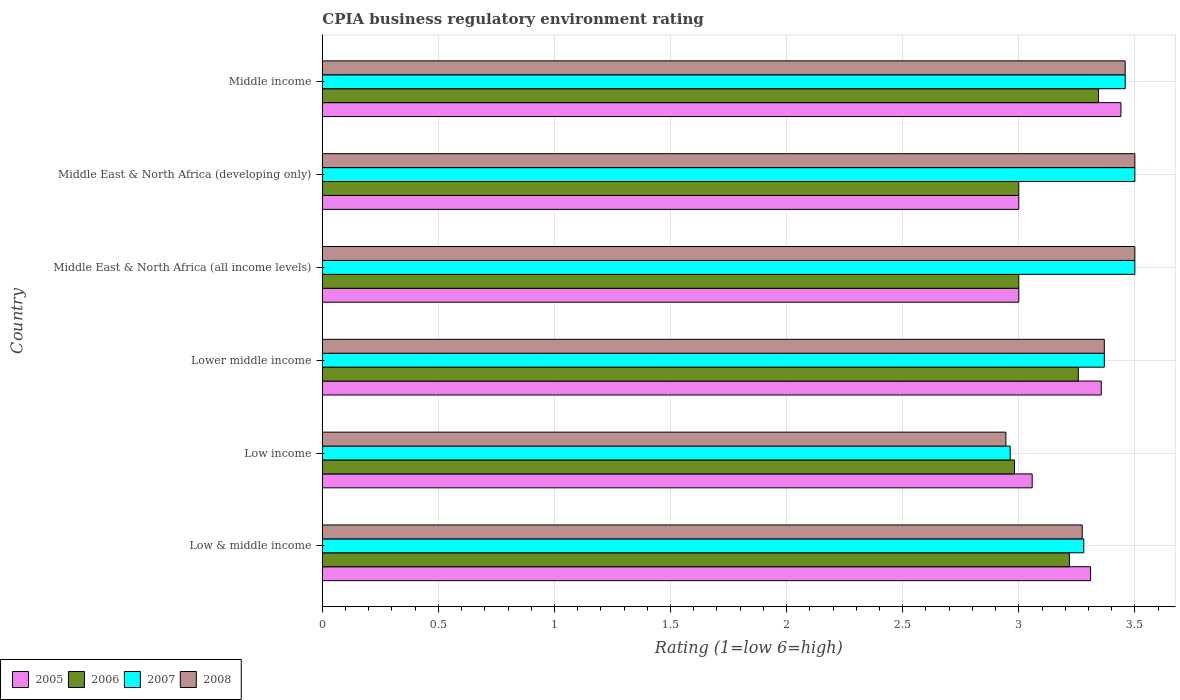How many bars are there on the 3rd tick from the top?
Keep it short and to the point. 4. In how many cases, is the number of bars for a given country not equal to the number of legend labels?
Your answer should be compact. 0. What is the CPIA rating in 2005 in Middle income?
Ensure brevity in your answer.  3.44. Across all countries, what is the maximum CPIA rating in 2006?
Ensure brevity in your answer.  3.34. Across all countries, what is the minimum CPIA rating in 2007?
Offer a terse response. 2.96. In which country was the CPIA rating in 2005 minimum?
Offer a terse response. Middle East & North Africa (all income levels). What is the total CPIA rating in 2005 in the graph?
Your answer should be very brief. 19.16. What is the difference between the CPIA rating in 2006 in Middle East & North Africa (all income levels) and that in Middle East & North Africa (developing only)?
Offer a terse response. 0. What is the difference between the CPIA rating in 2007 in Lower middle income and the CPIA rating in 2005 in Low income?
Offer a terse response. 0.31. What is the average CPIA rating in 2005 per country?
Make the answer very short. 3.19. In how many countries, is the CPIA rating in 2005 greater than 1 ?
Give a very brief answer. 6. What is the ratio of the CPIA rating in 2008 in Lower middle income to that in Middle East & North Africa (developing only)?
Keep it short and to the point. 0.96. What is the difference between the highest and the second highest CPIA rating in 2006?
Your response must be concise. 0.09. What is the difference between the highest and the lowest CPIA rating in 2006?
Provide a succinct answer. 0.36. Is the sum of the CPIA rating in 2005 in Lower middle income and Middle East & North Africa (all income levels) greater than the maximum CPIA rating in 2008 across all countries?
Offer a terse response. Yes. What does the 3rd bar from the bottom in Low & middle income represents?
Ensure brevity in your answer.  2007. How many bars are there?
Offer a terse response. 24. How many countries are there in the graph?
Your answer should be compact. 6. What is the difference between two consecutive major ticks on the X-axis?
Offer a terse response. 0.5. Does the graph contain any zero values?
Your response must be concise. No. Does the graph contain grids?
Your answer should be compact. Yes. Where does the legend appear in the graph?
Your answer should be compact. Bottom left. How are the legend labels stacked?
Your answer should be very brief. Horizontal. What is the title of the graph?
Keep it short and to the point. CPIA business regulatory environment rating. What is the label or title of the Y-axis?
Your answer should be compact. Country. What is the Rating (1=low 6=high) of 2005 in Low & middle income?
Keep it short and to the point. 3.31. What is the Rating (1=low 6=high) in 2006 in Low & middle income?
Your answer should be very brief. 3.22. What is the Rating (1=low 6=high) of 2007 in Low & middle income?
Your response must be concise. 3.28. What is the Rating (1=low 6=high) of 2008 in Low & middle income?
Give a very brief answer. 3.27. What is the Rating (1=low 6=high) in 2005 in Low income?
Provide a short and direct response. 3.06. What is the Rating (1=low 6=high) in 2006 in Low income?
Keep it short and to the point. 2.98. What is the Rating (1=low 6=high) in 2007 in Low income?
Offer a terse response. 2.96. What is the Rating (1=low 6=high) in 2008 in Low income?
Your response must be concise. 2.94. What is the Rating (1=low 6=high) of 2005 in Lower middle income?
Your answer should be very brief. 3.36. What is the Rating (1=low 6=high) of 2006 in Lower middle income?
Provide a short and direct response. 3.26. What is the Rating (1=low 6=high) in 2007 in Lower middle income?
Your answer should be compact. 3.37. What is the Rating (1=low 6=high) in 2008 in Lower middle income?
Your response must be concise. 3.37. What is the Rating (1=low 6=high) of 2005 in Middle East & North Africa (all income levels)?
Provide a succinct answer. 3. What is the Rating (1=low 6=high) in 2007 in Middle East & North Africa (all income levels)?
Provide a succinct answer. 3.5. What is the Rating (1=low 6=high) of 2005 in Middle East & North Africa (developing only)?
Your response must be concise. 3. What is the Rating (1=low 6=high) in 2007 in Middle East & North Africa (developing only)?
Offer a very short reply. 3.5. What is the Rating (1=low 6=high) of 2008 in Middle East & North Africa (developing only)?
Provide a short and direct response. 3.5. What is the Rating (1=low 6=high) in 2005 in Middle income?
Provide a short and direct response. 3.44. What is the Rating (1=low 6=high) in 2006 in Middle income?
Keep it short and to the point. 3.34. What is the Rating (1=low 6=high) of 2007 in Middle income?
Provide a succinct answer. 3.46. What is the Rating (1=low 6=high) in 2008 in Middle income?
Keep it short and to the point. 3.46. Across all countries, what is the maximum Rating (1=low 6=high) of 2005?
Keep it short and to the point. 3.44. Across all countries, what is the maximum Rating (1=low 6=high) in 2006?
Offer a very short reply. 3.34. Across all countries, what is the maximum Rating (1=low 6=high) in 2007?
Provide a short and direct response. 3.5. Across all countries, what is the minimum Rating (1=low 6=high) in 2006?
Your answer should be compact. 2.98. Across all countries, what is the minimum Rating (1=low 6=high) in 2007?
Offer a terse response. 2.96. Across all countries, what is the minimum Rating (1=low 6=high) of 2008?
Offer a terse response. 2.94. What is the total Rating (1=low 6=high) in 2005 in the graph?
Keep it short and to the point. 19.16. What is the total Rating (1=low 6=high) in 2006 in the graph?
Ensure brevity in your answer.  18.8. What is the total Rating (1=low 6=high) of 2007 in the graph?
Offer a very short reply. 20.07. What is the total Rating (1=low 6=high) of 2008 in the graph?
Your answer should be compact. 20.04. What is the difference between the Rating (1=low 6=high) of 2005 in Low & middle income and that in Low income?
Your answer should be very brief. 0.25. What is the difference between the Rating (1=low 6=high) in 2006 in Low & middle income and that in Low income?
Give a very brief answer. 0.24. What is the difference between the Rating (1=low 6=high) of 2007 in Low & middle income and that in Low income?
Give a very brief answer. 0.32. What is the difference between the Rating (1=low 6=high) in 2008 in Low & middle income and that in Low income?
Provide a short and direct response. 0.33. What is the difference between the Rating (1=low 6=high) in 2005 in Low & middle income and that in Lower middle income?
Your answer should be very brief. -0.05. What is the difference between the Rating (1=low 6=high) of 2006 in Low & middle income and that in Lower middle income?
Offer a very short reply. -0.04. What is the difference between the Rating (1=low 6=high) of 2007 in Low & middle income and that in Lower middle income?
Provide a succinct answer. -0.09. What is the difference between the Rating (1=low 6=high) in 2008 in Low & middle income and that in Lower middle income?
Give a very brief answer. -0.1. What is the difference between the Rating (1=low 6=high) of 2005 in Low & middle income and that in Middle East & North Africa (all income levels)?
Provide a succinct answer. 0.31. What is the difference between the Rating (1=low 6=high) of 2006 in Low & middle income and that in Middle East & North Africa (all income levels)?
Offer a very short reply. 0.22. What is the difference between the Rating (1=low 6=high) of 2007 in Low & middle income and that in Middle East & North Africa (all income levels)?
Your answer should be compact. -0.22. What is the difference between the Rating (1=low 6=high) of 2008 in Low & middle income and that in Middle East & North Africa (all income levels)?
Keep it short and to the point. -0.23. What is the difference between the Rating (1=low 6=high) of 2005 in Low & middle income and that in Middle East & North Africa (developing only)?
Give a very brief answer. 0.31. What is the difference between the Rating (1=low 6=high) in 2006 in Low & middle income and that in Middle East & North Africa (developing only)?
Provide a succinct answer. 0.22. What is the difference between the Rating (1=low 6=high) in 2007 in Low & middle income and that in Middle East & North Africa (developing only)?
Keep it short and to the point. -0.22. What is the difference between the Rating (1=low 6=high) in 2008 in Low & middle income and that in Middle East & North Africa (developing only)?
Offer a terse response. -0.23. What is the difference between the Rating (1=low 6=high) of 2005 in Low & middle income and that in Middle income?
Provide a succinct answer. -0.13. What is the difference between the Rating (1=low 6=high) of 2006 in Low & middle income and that in Middle income?
Provide a succinct answer. -0.13. What is the difference between the Rating (1=low 6=high) in 2007 in Low & middle income and that in Middle income?
Offer a terse response. -0.18. What is the difference between the Rating (1=low 6=high) in 2008 in Low & middle income and that in Middle income?
Your response must be concise. -0.18. What is the difference between the Rating (1=low 6=high) in 2005 in Low income and that in Lower middle income?
Provide a succinct answer. -0.3. What is the difference between the Rating (1=low 6=high) of 2006 in Low income and that in Lower middle income?
Your response must be concise. -0.27. What is the difference between the Rating (1=low 6=high) of 2007 in Low income and that in Lower middle income?
Provide a short and direct response. -0.41. What is the difference between the Rating (1=low 6=high) of 2008 in Low income and that in Lower middle income?
Your answer should be compact. -0.42. What is the difference between the Rating (1=low 6=high) in 2005 in Low income and that in Middle East & North Africa (all income levels)?
Your response must be concise. 0.06. What is the difference between the Rating (1=low 6=high) of 2006 in Low income and that in Middle East & North Africa (all income levels)?
Your answer should be very brief. -0.02. What is the difference between the Rating (1=low 6=high) of 2007 in Low income and that in Middle East & North Africa (all income levels)?
Give a very brief answer. -0.54. What is the difference between the Rating (1=low 6=high) in 2008 in Low income and that in Middle East & North Africa (all income levels)?
Keep it short and to the point. -0.56. What is the difference between the Rating (1=low 6=high) of 2005 in Low income and that in Middle East & North Africa (developing only)?
Your answer should be very brief. 0.06. What is the difference between the Rating (1=low 6=high) of 2006 in Low income and that in Middle East & North Africa (developing only)?
Your response must be concise. -0.02. What is the difference between the Rating (1=low 6=high) in 2007 in Low income and that in Middle East & North Africa (developing only)?
Keep it short and to the point. -0.54. What is the difference between the Rating (1=low 6=high) of 2008 in Low income and that in Middle East & North Africa (developing only)?
Provide a short and direct response. -0.56. What is the difference between the Rating (1=low 6=high) in 2005 in Low income and that in Middle income?
Give a very brief answer. -0.38. What is the difference between the Rating (1=low 6=high) of 2006 in Low income and that in Middle income?
Ensure brevity in your answer.  -0.36. What is the difference between the Rating (1=low 6=high) in 2007 in Low income and that in Middle income?
Offer a terse response. -0.5. What is the difference between the Rating (1=low 6=high) in 2008 in Low income and that in Middle income?
Offer a terse response. -0.51. What is the difference between the Rating (1=low 6=high) of 2005 in Lower middle income and that in Middle East & North Africa (all income levels)?
Ensure brevity in your answer.  0.36. What is the difference between the Rating (1=low 6=high) of 2006 in Lower middle income and that in Middle East & North Africa (all income levels)?
Offer a terse response. 0.26. What is the difference between the Rating (1=low 6=high) of 2007 in Lower middle income and that in Middle East & North Africa (all income levels)?
Provide a short and direct response. -0.13. What is the difference between the Rating (1=low 6=high) of 2008 in Lower middle income and that in Middle East & North Africa (all income levels)?
Your response must be concise. -0.13. What is the difference between the Rating (1=low 6=high) of 2005 in Lower middle income and that in Middle East & North Africa (developing only)?
Offer a very short reply. 0.36. What is the difference between the Rating (1=low 6=high) of 2006 in Lower middle income and that in Middle East & North Africa (developing only)?
Give a very brief answer. 0.26. What is the difference between the Rating (1=low 6=high) in 2007 in Lower middle income and that in Middle East & North Africa (developing only)?
Give a very brief answer. -0.13. What is the difference between the Rating (1=low 6=high) of 2008 in Lower middle income and that in Middle East & North Africa (developing only)?
Your response must be concise. -0.13. What is the difference between the Rating (1=low 6=high) of 2005 in Lower middle income and that in Middle income?
Your answer should be very brief. -0.08. What is the difference between the Rating (1=low 6=high) of 2006 in Lower middle income and that in Middle income?
Offer a very short reply. -0.09. What is the difference between the Rating (1=low 6=high) of 2007 in Lower middle income and that in Middle income?
Your answer should be very brief. -0.09. What is the difference between the Rating (1=low 6=high) in 2008 in Lower middle income and that in Middle income?
Provide a short and direct response. -0.09. What is the difference between the Rating (1=low 6=high) of 2005 in Middle East & North Africa (all income levels) and that in Middle income?
Your answer should be compact. -0.44. What is the difference between the Rating (1=low 6=high) in 2006 in Middle East & North Africa (all income levels) and that in Middle income?
Ensure brevity in your answer.  -0.34. What is the difference between the Rating (1=low 6=high) in 2007 in Middle East & North Africa (all income levels) and that in Middle income?
Offer a terse response. 0.04. What is the difference between the Rating (1=low 6=high) of 2008 in Middle East & North Africa (all income levels) and that in Middle income?
Offer a very short reply. 0.04. What is the difference between the Rating (1=low 6=high) of 2005 in Middle East & North Africa (developing only) and that in Middle income?
Give a very brief answer. -0.44. What is the difference between the Rating (1=low 6=high) of 2006 in Middle East & North Africa (developing only) and that in Middle income?
Your answer should be very brief. -0.34. What is the difference between the Rating (1=low 6=high) of 2007 in Middle East & North Africa (developing only) and that in Middle income?
Offer a very short reply. 0.04. What is the difference between the Rating (1=low 6=high) of 2008 in Middle East & North Africa (developing only) and that in Middle income?
Your answer should be compact. 0.04. What is the difference between the Rating (1=low 6=high) in 2005 in Low & middle income and the Rating (1=low 6=high) in 2006 in Low income?
Keep it short and to the point. 0.33. What is the difference between the Rating (1=low 6=high) in 2005 in Low & middle income and the Rating (1=low 6=high) in 2007 in Low income?
Provide a short and direct response. 0.35. What is the difference between the Rating (1=low 6=high) in 2005 in Low & middle income and the Rating (1=low 6=high) in 2008 in Low income?
Offer a terse response. 0.36. What is the difference between the Rating (1=low 6=high) in 2006 in Low & middle income and the Rating (1=low 6=high) in 2007 in Low income?
Your response must be concise. 0.26. What is the difference between the Rating (1=low 6=high) in 2006 in Low & middle income and the Rating (1=low 6=high) in 2008 in Low income?
Keep it short and to the point. 0.27. What is the difference between the Rating (1=low 6=high) of 2007 in Low & middle income and the Rating (1=low 6=high) of 2008 in Low income?
Your answer should be compact. 0.34. What is the difference between the Rating (1=low 6=high) in 2005 in Low & middle income and the Rating (1=low 6=high) in 2006 in Lower middle income?
Offer a very short reply. 0.05. What is the difference between the Rating (1=low 6=high) in 2005 in Low & middle income and the Rating (1=low 6=high) in 2007 in Lower middle income?
Your answer should be compact. -0.06. What is the difference between the Rating (1=low 6=high) of 2005 in Low & middle income and the Rating (1=low 6=high) of 2008 in Lower middle income?
Offer a terse response. -0.06. What is the difference between the Rating (1=low 6=high) of 2006 in Low & middle income and the Rating (1=low 6=high) of 2007 in Lower middle income?
Make the answer very short. -0.15. What is the difference between the Rating (1=low 6=high) of 2006 in Low & middle income and the Rating (1=low 6=high) of 2008 in Lower middle income?
Provide a short and direct response. -0.15. What is the difference between the Rating (1=low 6=high) of 2007 in Low & middle income and the Rating (1=low 6=high) of 2008 in Lower middle income?
Make the answer very short. -0.09. What is the difference between the Rating (1=low 6=high) of 2005 in Low & middle income and the Rating (1=low 6=high) of 2006 in Middle East & North Africa (all income levels)?
Your response must be concise. 0.31. What is the difference between the Rating (1=low 6=high) of 2005 in Low & middle income and the Rating (1=low 6=high) of 2007 in Middle East & North Africa (all income levels)?
Offer a terse response. -0.19. What is the difference between the Rating (1=low 6=high) in 2005 in Low & middle income and the Rating (1=low 6=high) in 2008 in Middle East & North Africa (all income levels)?
Offer a terse response. -0.19. What is the difference between the Rating (1=low 6=high) of 2006 in Low & middle income and the Rating (1=low 6=high) of 2007 in Middle East & North Africa (all income levels)?
Keep it short and to the point. -0.28. What is the difference between the Rating (1=low 6=high) of 2006 in Low & middle income and the Rating (1=low 6=high) of 2008 in Middle East & North Africa (all income levels)?
Your answer should be very brief. -0.28. What is the difference between the Rating (1=low 6=high) in 2007 in Low & middle income and the Rating (1=low 6=high) in 2008 in Middle East & North Africa (all income levels)?
Give a very brief answer. -0.22. What is the difference between the Rating (1=low 6=high) of 2005 in Low & middle income and the Rating (1=low 6=high) of 2006 in Middle East & North Africa (developing only)?
Ensure brevity in your answer.  0.31. What is the difference between the Rating (1=low 6=high) in 2005 in Low & middle income and the Rating (1=low 6=high) in 2007 in Middle East & North Africa (developing only)?
Keep it short and to the point. -0.19. What is the difference between the Rating (1=low 6=high) in 2005 in Low & middle income and the Rating (1=low 6=high) in 2008 in Middle East & North Africa (developing only)?
Your answer should be very brief. -0.19. What is the difference between the Rating (1=low 6=high) in 2006 in Low & middle income and the Rating (1=low 6=high) in 2007 in Middle East & North Africa (developing only)?
Your answer should be compact. -0.28. What is the difference between the Rating (1=low 6=high) in 2006 in Low & middle income and the Rating (1=low 6=high) in 2008 in Middle East & North Africa (developing only)?
Keep it short and to the point. -0.28. What is the difference between the Rating (1=low 6=high) of 2007 in Low & middle income and the Rating (1=low 6=high) of 2008 in Middle East & North Africa (developing only)?
Give a very brief answer. -0.22. What is the difference between the Rating (1=low 6=high) of 2005 in Low & middle income and the Rating (1=low 6=high) of 2006 in Middle income?
Your answer should be compact. -0.03. What is the difference between the Rating (1=low 6=high) in 2005 in Low & middle income and the Rating (1=low 6=high) in 2007 in Middle income?
Keep it short and to the point. -0.15. What is the difference between the Rating (1=low 6=high) in 2005 in Low & middle income and the Rating (1=low 6=high) in 2008 in Middle income?
Offer a terse response. -0.15. What is the difference between the Rating (1=low 6=high) of 2006 in Low & middle income and the Rating (1=low 6=high) of 2007 in Middle income?
Your answer should be very brief. -0.24. What is the difference between the Rating (1=low 6=high) of 2006 in Low & middle income and the Rating (1=low 6=high) of 2008 in Middle income?
Ensure brevity in your answer.  -0.24. What is the difference between the Rating (1=low 6=high) of 2007 in Low & middle income and the Rating (1=low 6=high) of 2008 in Middle income?
Your answer should be very brief. -0.18. What is the difference between the Rating (1=low 6=high) of 2005 in Low income and the Rating (1=low 6=high) of 2006 in Lower middle income?
Offer a very short reply. -0.2. What is the difference between the Rating (1=low 6=high) in 2005 in Low income and the Rating (1=low 6=high) in 2007 in Lower middle income?
Offer a terse response. -0.31. What is the difference between the Rating (1=low 6=high) of 2005 in Low income and the Rating (1=low 6=high) of 2008 in Lower middle income?
Make the answer very short. -0.31. What is the difference between the Rating (1=low 6=high) of 2006 in Low income and the Rating (1=low 6=high) of 2007 in Lower middle income?
Your response must be concise. -0.39. What is the difference between the Rating (1=low 6=high) in 2006 in Low income and the Rating (1=low 6=high) in 2008 in Lower middle income?
Make the answer very short. -0.39. What is the difference between the Rating (1=low 6=high) of 2007 in Low income and the Rating (1=low 6=high) of 2008 in Lower middle income?
Keep it short and to the point. -0.41. What is the difference between the Rating (1=low 6=high) in 2005 in Low income and the Rating (1=low 6=high) in 2006 in Middle East & North Africa (all income levels)?
Your response must be concise. 0.06. What is the difference between the Rating (1=low 6=high) in 2005 in Low income and the Rating (1=low 6=high) in 2007 in Middle East & North Africa (all income levels)?
Your response must be concise. -0.44. What is the difference between the Rating (1=low 6=high) of 2005 in Low income and the Rating (1=low 6=high) of 2008 in Middle East & North Africa (all income levels)?
Provide a succinct answer. -0.44. What is the difference between the Rating (1=low 6=high) of 2006 in Low income and the Rating (1=low 6=high) of 2007 in Middle East & North Africa (all income levels)?
Make the answer very short. -0.52. What is the difference between the Rating (1=low 6=high) of 2006 in Low income and the Rating (1=low 6=high) of 2008 in Middle East & North Africa (all income levels)?
Keep it short and to the point. -0.52. What is the difference between the Rating (1=low 6=high) of 2007 in Low income and the Rating (1=low 6=high) of 2008 in Middle East & North Africa (all income levels)?
Keep it short and to the point. -0.54. What is the difference between the Rating (1=low 6=high) of 2005 in Low income and the Rating (1=low 6=high) of 2006 in Middle East & North Africa (developing only)?
Provide a short and direct response. 0.06. What is the difference between the Rating (1=low 6=high) in 2005 in Low income and the Rating (1=low 6=high) in 2007 in Middle East & North Africa (developing only)?
Your answer should be very brief. -0.44. What is the difference between the Rating (1=low 6=high) of 2005 in Low income and the Rating (1=low 6=high) of 2008 in Middle East & North Africa (developing only)?
Make the answer very short. -0.44. What is the difference between the Rating (1=low 6=high) in 2006 in Low income and the Rating (1=low 6=high) in 2007 in Middle East & North Africa (developing only)?
Give a very brief answer. -0.52. What is the difference between the Rating (1=low 6=high) of 2006 in Low income and the Rating (1=low 6=high) of 2008 in Middle East & North Africa (developing only)?
Provide a succinct answer. -0.52. What is the difference between the Rating (1=low 6=high) of 2007 in Low income and the Rating (1=low 6=high) of 2008 in Middle East & North Africa (developing only)?
Offer a very short reply. -0.54. What is the difference between the Rating (1=low 6=high) of 2005 in Low income and the Rating (1=low 6=high) of 2006 in Middle income?
Your answer should be compact. -0.29. What is the difference between the Rating (1=low 6=high) of 2005 in Low income and the Rating (1=low 6=high) of 2007 in Middle income?
Your response must be concise. -0.4. What is the difference between the Rating (1=low 6=high) in 2005 in Low income and the Rating (1=low 6=high) in 2008 in Middle income?
Your answer should be compact. -0.4. What is the difference between the Rating (1=low 6=high) of 2006 in Low income and the Rating (1=low 6=high) of 2007 in Middle income?
Provide a succinct answer. -0.48. What is the difference between the Rating (1=low 6=high) in 2006 in Low income and the Rating (1=low 6=high) in 2008 in Middle income?
Your answer should be compact. -0.48. What is the difference between the Rating (1=low 6=high) in 2007 in Low income and the Rating (1=low 6=high) in 2008 in Middle income?
Give a very brief answer. -0.5. What is the difference between the Rating (1=low 6=high) in 2005 in Lower middle income and the Rating (1=low 6=high) in 2006 in Middle East & North Africa (all income levels)?
Keep it short and to the point. 0.36. What is the difference between the Rating (1=low 6=high) of 2005 in Lower middle income and the Rating (1=low 6=high) of 2007 in Middle East & North Africa (all income levels)?
Make the answer very short. -0.14. What is the difference between the Rating (1=low 6=high) of 2005 in Lower middle income and the Rating (1=low 6=high) of 2008 in Middle East & North Africa (all income levels)?
Provide a succinct answer. -0.14. What is the difference between the Rating (1=low 6=high) of 2006 in Lower middle income and the Rating (1=low 6=high) of 2007 in Middle East & North Africa (all income levels)?
Provide a short and direct response. -0.24. What is the difference between the Rating (1=low 6=high) in 2006 in Lower middle income and the Rating (1=low 6=high) in 2008 in Middle East & North Africa (all income levels)?
Provide a short and direct response. -0.24. What is the difference between the Rating (1=low 6=high) in 2007 in Lower middle income and the Rating (1=low 6=high) in 2008 in Middle East & North Africa (all income levels)?
Give a very brief answer. -0.13. What is the difference between the Rating (1=low 6=high) of 2005 in Lower middle income and the Rating (1=low 6=high) of 2006 in Middle East & North Africa (developing only)?
Ensure brevity in your answer.  0.36. What is the difference between the Rating (1=low 6=high) of 2005 in Lower middle income and the Rating (1=low 6=high) of 2007 in Middle East & North Africa (developing only)?
Give a very brief answer. -0.14. What is the difference between the Rating (1=low 6=high) of 2005 in Lower middle income and the Rating (1=low 6=high) of 2008 in Middle East & North Africa (developing only)?
Your response must be concise. -0.14. What is the difference between the Rating (1=low 6=high) of 2006 in Lower middle income and the Rating (1=low 6=high) of 2007 in Middle East & North Africa (developing only)?
Keep it short and to the point. -0.24. What is the difference between the Rating (1=low 6=high) in 2006 in Lower middle income and the Rating (1=low 6=high) in 2008 in Middle East & North Africa (developing only)?
Provide a short and direct response. -0.24. What is the difference between the Rating (1=low 6=high) in 2007 in Lower middle income and the Rating (1=low 6=high) in 2008 in Middle East & North Africa (developing only)?
Keep it short and to the point. -0.13. What is the difference between the Rating (1=low 6=high) in 2005 in Lower middle income and the Rating (1=low 6=high) in 2006 in Middle income?
Provide a short and direct response. 0.01. What is the difference between the Rating (1=low 6=high) of 2005 in Lower middle income and the Rating (1=low 6=high) of 2007 in Middle income?
Your answer should be very brief. -0.1. What is the difference between the Rating (1=low 6=high) in 2005 in Lower middle income and the Rating (1=low 6=high) in 2008 in Middle income?
Give a very brief answer. -0.1. What is the difference between the Rating (1=low 6=high) in 2006 in Lower middle income and the Rating (1=low 6=high) in 2007 in Middle income?
Provide a short and direct response. -0.2. What is the difference between the Rating (1=low 6=high) of 2006 in Lower middle income and the Rating (1=low 6=high) of 2008 in Middle income?
Your answer should be compact. -0.2. What is the difference between the Rating (1=low 6=high) of 2007 in Lower middle income and the Rating (1=low 6=high) of 2008 in Middle income?
Ensure brevity in your answer.  -0.09. What is the difference between the Rating (1=low 6=high) in 2005 in Middle East & North Africa (all income levels) and the Rating (1=low 6=high) in 2006 in Middle income?
Offer a very short reply. -0.34. What is the difference between the Rating (1=low 6=high) of 2005 in Middle East & North Africa (all income levels) and the Rating (1=low 6=high) of 2007 in Middle income?
Give a very brief answer. -0.46. What is the difference between the Rating (1=low 6=high) of 2005 in Middle East & North Africa (all income levels) and the Rating (1=low 6=high) of 2008 in Middle income?
Give a very brief answer. -0.46. What is the difference between the Rating (1=low 6=high) in 2006 in Middle East & North Africa (all income levels) and the Rating (1=low 6=high) in 2007 in Middle income?
Offer a very short reply. -0.46. What is the difference between the Rating (1=low 6=high) of 2006 in Middle East & North Africa (all income levels) and the Rating (1=low 6=high) of 2008 in Middle income?
Your response must be concise. -0.46. What is the difference between the Rating (1=low 6=high) of 2007 in Middle East & North Africa (all income levels) and the Rating (1=low 6=high) of 2008 in Middle income?
Provide a short and direct response. 0.04. What is the difference between the Rating (1=low 6=high) in 2005 in Middle East & North Africa (developing only) and the Rating (1=low 6=high) in 2006 in Middle income?
Make the answer very short. -0.34. What is the difference between the Rating (1=low 6=high) in 2005 in Middle East & North Africa (developing only) and the Rating (1=low 6=high) in 2007 in Middle income?
Offer a terse response. -0.46. What is the difference between the Rating (1=low 6=high) in 2005 in Middle East & North Africa (developing only) and the Rating (1=low 6=high) in 2008 in Middle income?
Your answer should be very brief. -0.46. What is the difference between the Rating (1=low 6=high) in 2006 in Middle East & North Africa (developing only) and the Rating (1=low 6=high) in 2007 in Middle income?
Give a very brief answer. -0.46. What is the difference between the Rating (1=low 6=high) in 2006 in Middle East & North Africa (developing only) and the Rating (1=low 6=high) in 2008 in Middle income?
Keep it short and to the point. -0.46. What is the difference between the Rating (1=low 6=high) of 2007 in Middle East & North Africa (developing only) and the Rating (1=low 6=high) of 2008 in Middle income?
Make the answer very short. 0.04. What is the average Rating (1=low 6=high) of 2005 per country?
Keep it short and to the point. 3.19. What is the average Rating (1=low 6=high) in 2006 per country?
Give a very brief answer. 3.13. What is the average Rating (1=low 6=high) in 2007 per country?
Keep it short and to the point. 3.35. What is the average Rating (1=low 6=high) in 2008 per country?
Ensure brevity in your answer.  3.34. What is the difference between the Rating (1=low 6=high) in 2005 and Rating (1=low 6=high) in 2006 in Low & middle income?
Ensure brevity in your answer.  0.09. What is the difference between the Rating (1=low 6=high) in 2005 and Rating (1=low 6=high) in 2007 in Low & middle income?
Offer a very short reply. 0.03. What is the difference between the Rating (1=low 6=high) in 2005 and Rating (1=low 6=high) in 2008 in Low & middle income?
Ensure brevity in your answer.  0.04. What is the difference between the Rating (1=low 6=high) of 2006 and Rating (1=low 6=high) of 2007 in Low & middle income?
Offer a terse response. -0.06. What is the difference between the Rating (1=low 6=high) in 2006 and Rating (1=low 6=high) in 2008 in Low & middle income?
Ensure brevity in your answer.  -0.06. What is the difference between the Rating (1=low 6=high) in 2007 and Rating (1=low 6=high) in 2008 in Low & middle income?
Keep it short and to the point. 0.01. What is the difference between the Rating (1=low 6=high) in 2005 and Rating (1=low 6=high) in 2006 in Low income?
Offer a terse response. 0.08. What is the difference between the Rating (1=low 6=high) in 2005 and Rating (1=low 6=high) in 2007 in Low income?
Your answer should be compact. 0.09. What is the difference between the Rating (1=low 6=high) of 2005 and Rating (1=low 6=high) of 2008 in Low income?
Your answer should be compact. 0.11. What is the difference between the Rating (1=low 6=high) of 2006 and Rating (1=low 6=high) of 2007 in Low income?
Offer a very short reply. 0.02. What is the difference between the Rating (1=low 6=high) in 2006 and Rating (1=low 6=high) in 2008 in Low income?
Keep it short and to the point. 0.04. What is the difference between the Rating (1=low 6=high) in 2007 and Rating (1=low 6=high) in 2008 in Low income?
Make the answer very short. 0.02. What is the difference between the Rating (1=low 6=high) in 2005 and Rating (1=low 6=high) in 2006 in Lower middle income?
Your answer should be compact. 0.1. What is the difference between the Rating (1=low 6=high) in 2005 and Rating (1=low 6=high) in 2007 in Lower middle income?
Offer a terse response. -0.01. What is the difference between the Rating (1=low 6=high) in 2005 and Rating (1=low 6=high) in 2008 in Lower middle income?
Offer a terse response. -0.01. What is the difference between the Rating (1=low 6=high) in 2006 and Rating (1=low 6=high) in 2007 in Lower middle income?
Give a very brief answer. -0.11. What is the difference between the Rating (1=low 6=high) of 2006 and Rating (1=low 6=high) of 2008 in Lower middle income?
Your response must be concise. -0.11. What is the difference between the Rating (1=low 6=high) of 2005 and Rating (1=low 6=high) of 2006 in Middle East & North Africa (all income levels)?
Your answer should be very brief. 0. What is the difference between the Rating (1=low 6=high) of 2007 and Rating (1=low 6=high) of 2008 in Middle East & North Africa (all income levels)?
Your response must be concise. 0. What is the difference between the Rating (1=low 6=high) of 2005 and Rating (1=low 6=high) of 2007 in Middle East & North Africa (developing only)?
Offer a terse response. -0.5. What is the difference between the Rating (1=low 6=high) of 2005 and Rating (1=low 6=high) of 2008 in Middle East & North Africa (developing only)?
Offer a very short reply. -0.5. What is the difference between the Rating (1=low 6=high) of 2006 and Rating (1=low 6=high) of 2007 in Middle East & North Africa (developing only)?
Make the answer very short. -0.5. What is the difference between the Rating (1=low 6=high) of 2005 and Rating (1=low 6=high) of 2006 in Middle income?
Provide a succinct answer. 0.1. What is the difference between the Rating (1=low 6=high) in 2005 and Rating (1=low 6=high) in 2007 in Middle income?
Ensure brevity in your answer.  -0.02. What is the difference between the Rating (1=low 6=high) in 2005 and Rating (1=low 6=high) in 2008 in Middle income?
Keep it short and to the point. -0.02. What is the difference between the Rating (1=low 6=high) of 2006 and Rating (1=low 6=high) of 2007 in Middle income?
Provide a short and direct response. -0.12. What is the difference between the Rating (1=low 6=high) in 2006 and Rating (1=low 6=high) in 2008 in Middle income?
Keep it short and to the point. -0.12. What is the ratio of the Rating (1=low 6=high) of 2005 in Low & middle income to that in Low income?
Your response must be concise. 1.08. What is the ratio of the Rating (1=low 6=high) in 2006 in Low & middle income to that in Low income?
Keep it short and to the point. 1.08. What is the ratio of the Rating (1=low 6=high) of 2007 in Low & middle income to that in Low income?
Keep it short and to the point. 1.11. What is the ratio of the Rating (1=low 6=high) in 2008 in Low & middle income to that in Low income?
Your answer should be very brief. 1.11. What is the ratio of the Rating (1=low 6=high) in 2005 in Low & middle income to that in Lower middle income?
Make the answer very short. 0.99. What is the ratio of the Rating (1=low 6=high) in 2006 in Low & middle income to that in Lower middle income?
Your answer should be very brief. 0.99. What is the ratio of the Rating (1=low 6=high) of 2007 in Low & middle income to that in Lower middle income?
Make the answer very short. 0.97. What is the ratio of the Rating (1=low 6=high) of 2008 in Low & middle income to that in Lower middle income?
Provide a succinct answer. 0.97. What is the ratio of the Rating (1=low 6=high) in 2005 in Low & middle income to that in Middle East & North Africa (all income levels)?
Ensure brevity in your answer.  1.1. What is the ratio of the Rating (1=low 6=high) in 2006 in Low & middle income to that in Middle East & North Africa (all income levels)?
Offer a very short reply. 1.07. What is the ratio of the Rating (1=low 6=high) in 2007 in Low & middle income to that in Middle East & North Africa (all income levels)?
Your response must be concise. 0.94. What is the ratio of the Rating (1=low 6=high) in 2008 in Low & middle income to that in Middle East & North Africa (all income levels)?
Give a very brief answer. 0.94. What is the ratio of the Rating (1=low 6=high) in 2005 in Low & middle income to that in Middle East & North Africa (developing only)?
Offer a terse response. 1.1. What is the ratio of the Rating (1=low 6=high) in 2006 in Low & middle income to that in Middle East & North Africa (developing only)?
Keep it short and to the point. 1.07. What is the ratio of the Rating (1=low 6=high) of 2007 in Low & middle income to that in Middle East & North Africa (developing only)?
Keep it short and to the point. 0.94. What is the ratio of the Rating (1=low 6=high) of 2008 in Low & middle income to that in Middle East & North Africa (developing only)?
Your answer should be very brief. 0.94. What is the ratio of the Rating (1=low 6=high) in 2005 in Low & middle income to that in Middle income?
Your response must be concise. 0.96. What is the ratio of the Rating (1=low 6=high) in 2006 in Low & middle income to that in Middle income?
Keep it short and to the point. 0.96. What is the ratio of the Rating (1=low 6=high) in 2007 in Low & middle income to that in Middle income?
Your response must be concise. 0.95. What is the ratio of the Rating (1=low 6=high) of 2008 in Low & middle income to that in Middle income?
Your answer should be compact. 0.95. What is the ratio of the Rating (1=low 6=high) in 2005 in Low income to that in Lower middle income?
Make the answer very short. 0.91. What is the ratio of the Rating (1=low 6=high) in 2006 in Low income to that in Lower middle income?
Give a very brief answer. 0.92. What is the ratio of the Rating (1=low 6=high) of 2007 in Low income to that in Lower middle income?
Make the answer very short. 0.88. What is the ratio of the Rating (1=low 6=high) in 2008 in Low income to that in Lower middle income?
Make the answer very short. 0.87. What is the ratio of the Rating (1=low 6=high) of 2005 in Low income to that in Middle East & North Africa (all income levels)?
Your response must be concise. 1.02. What is the ratio of the Rating (1=low 6=high) in 2007 in Low income to that in Middle East & North Africa (all income levels)?
Ensure brevity in your answer.  0.85. What is the ratio of the Rating (1=low 6=high) in 2008 in Low income to that in Middle East & North Africa (all income levels)?
Your answer should be compact. 0.84. What is the ratio of the Rating (1=low 6=high) in 2005 in Low income to that in Middle East & North Africa (developing only)?
Your answer should be compact. 1.02. What is the ratio of the Rating (1=low 6=high) of 2007 in Low income to that in Middle East & North Africa (developing only)?
Make the answer very short. 0.85. What is the ratio of the Rating (1=low 6=high) of 2008 in Low income to that in Middle East & North Africa (developing only)?
Make the answer very short. 0.84. What is the ratio of the Rating (1=low 6=high) in 2006 in Low income to that in Middle income?
Your answer should be compact. 0.89. What is the ratio of the Rating (1=low 6=high) in 2007 in Low income to that in Middle income?
Provide a succinct answer. 0.86. What is the ratio of the Rating (1=low 6=high) of 2008 in Low income to that in Middle income?
Offer a very short reply. 0.85. What is the ratio of the Rating (1=low 6=high) of 2005 in Lower middle income to that in Middle East & North Africa (all income levels)?
Your answer should be very brief. 1.12. What is the ratio of the Rating (1=low 6=high) of 2006 in Lower middle income to that in Middle East & North Africa (all income levels)?
Give a very brief answer. 1.09. What is the ratio of the Rating (1=low 6=high) of 2007 in Lower middle income to that in Middle East & North Africa (all income levels)?
Your response must be concise. 0.96. What is the ratio of the Rating (1=low 6=high) of 2008 in Lower middle income to that in Middle East & North Africa (all income levels)?
Offer a terse response. 0.96. What is the ratio of the Rating (1=low 6=high) in 2005 in Lower middle income to that in Middle East & North Africa (developing only)?
Your answer should be very brief. 1.12. What is the ratio of the Rating (1=low 6=high) in 2006 in Lower middle income to that in Middle East & North Africa (developing only)?
Your response must be concise. 1.09. What is the ratio of the Rating (1=low 6=high) in 2007 in Lower middle income to that in Middle East & North Africa (developing only)?
Give a very brief answer. 0.96. What is the ratio of the Rating (1=low 6=high) of 2008 in Lower middle income to that in Middle East & North Africa (developing only)?
Offer a very short reply. 0.96. What is the ratio of the Rating (1=low 6=high) in 2005 in Lower middle income to that in Middle income?
Ensure brevity in your answer.  0.98. What is the ratio of the Rating (1=low 6=high) of 2006 in Lower middle income to that in Middle income?
Give a very brief answer. 0.97. What is the ratio of the Rating (1=low 6=high) in 2007 in Lower middle income to that in Middle income?
Give a very brief answer. 0.97. What is the ratio of the Rating (1=low 6=high) in 2008 in Lower middle income to that in Middle income?
Provide a succinct answer. 0.97. What is the ratio of the Rating (1=low 6=high) of 2005 in Middle East & North Africa (all income levels) to that in Middle East & North Africa (developing only)?
Keep it short and to the point. 1. What is the ratio of the Rating (1=low 6=high) of 2005 in Middle East & North Africa (all income levels) to that in Middle income?
Your answer should be very brief. 0.87. What is the ratio of the Rating (1=low 6=high) of 2006 in Middle East & North Africa (all income levels) to that in Middle income?
Provide a succinct answer. 0.9. What is the ratio of the Rating (1=low 6=high) in 2007 in Middle East & North Africa (all income levels) to that in Middle income?
Provide a succinct answer. 1.01. What is the ratio of the Rating (1=low 6=high) of 2008 in Middle East & North Africa (all income levels) to that in Middle income?
Your response must be concise. 1.01. What is the ratio of the Rating (1=low 6=high) of 2005 in Middle East & North Africa (developing only) to that in Middle income?
Offer a terse response. 0.87. What is the ratio of the Rating (1=low 6=high) of 2006 in Middle East & North Africa (developing only) to that in Middle income?
Offer a very short reply. 0.9. What is the ratio of the Rating (1=low 6=high) of 2008 in Middle East & North Africa (developing only) to that in Middle income?
Ensure brevity in your answer.  1.01. What is the difference between the highest and the second highest Rating (1=low 6=high) of 2005?
Provide a succinct answer. 0.08. What is the difference between the highest and the second highest Rating (1=low 6=high) of 2006?
Ensure brevity in your answer.  0.09. What is the difference between the highest and the second highest Rating (1=low 6=high) of 2008?
Ensure brevity in your answer.  0. What is the difference between the highest and the lowest Rating (1=low 6=high) in 2005?
Ensure brevity in your answer.  0.44. What is the difference between the highest and the lowest Rating (1=low 6=high) of 2006?
Your answer should be compact. 0.36. What is the difference between the highest and the lowest Rating (1=low 6=high) in 2007?
Provide a succinct answer. 0.54. What is the difference between the highest and the lowest Rating (1=low 6=high) of 2008?
Your response must be concise. 0.56. 